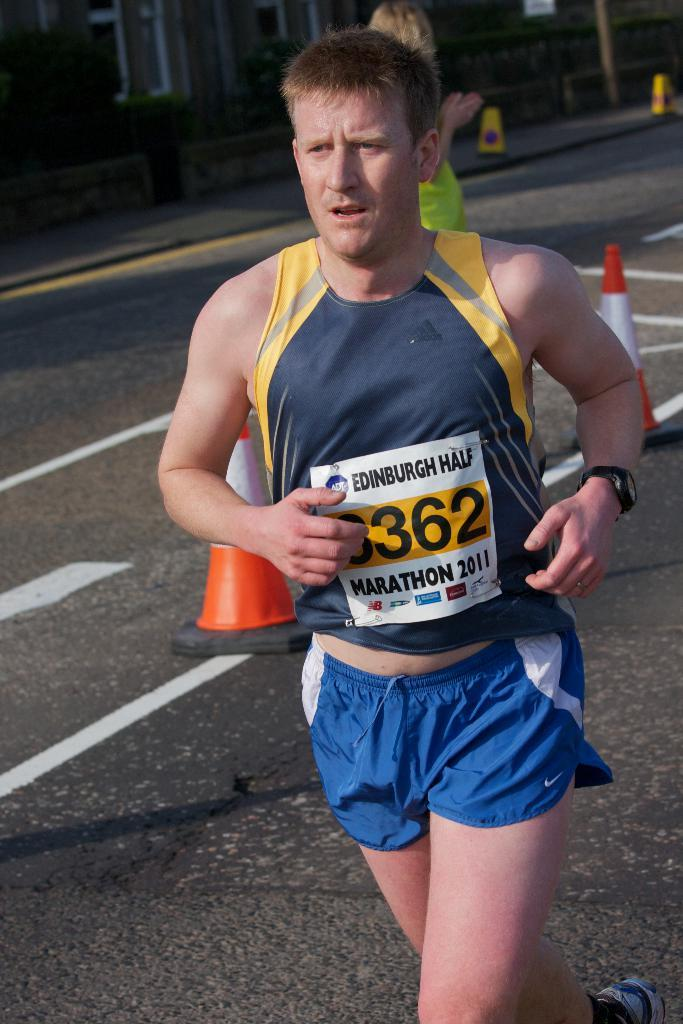<image>
Share a concise interpretation of the image provided. an edinburgh half marathon runner running his marathon 